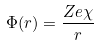Convert formula to latex. <formula><loc_0><loc_0><loc_500><loc_500>\Phi ( r ) = \frac { Z e \chi } { r }</formula> 